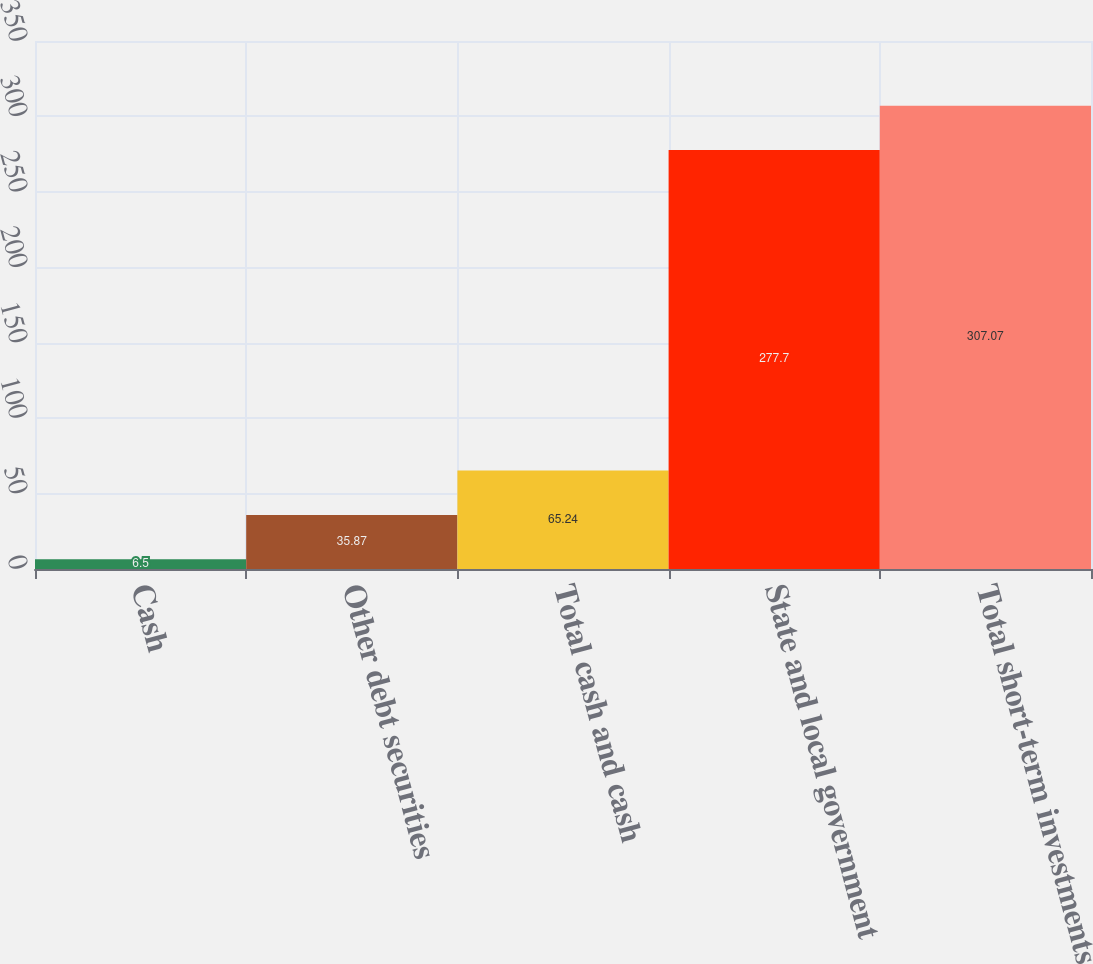Convert chart. <chart><loc_0><loc_0><loc_500><loc_500><bar_chart><fcel>Cash<fcel>Other debt securities<fcel>Total cash and cash<fcel>State and local government<fcel>Total short-term investments<nl><fcel>6.5<fcel>35.87<fcel>65.24<fcel>277.7<fcel>307.07<nl></chart> 